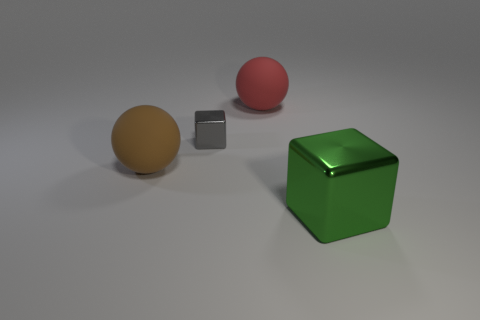Add 2 rubber balls. How many objects exist? 6 Subtract 1 blocks. How many blocks are left? 1 Subtract all gray cubes. How many cubes are left? 1 Add 1 purple cylinders. How many purple cylinders exist? 1 Subtract 0 blue cylinders. How many objects are left? 4 Subtract all gray cubes. Subtract all gray spheres. How many cubes are left? 1 Subtract all gray shiny blocks. Subtract all large green shiny blocks. How many objects are left? 2 Add 4 big red objects. How many big red objects are left? 5 